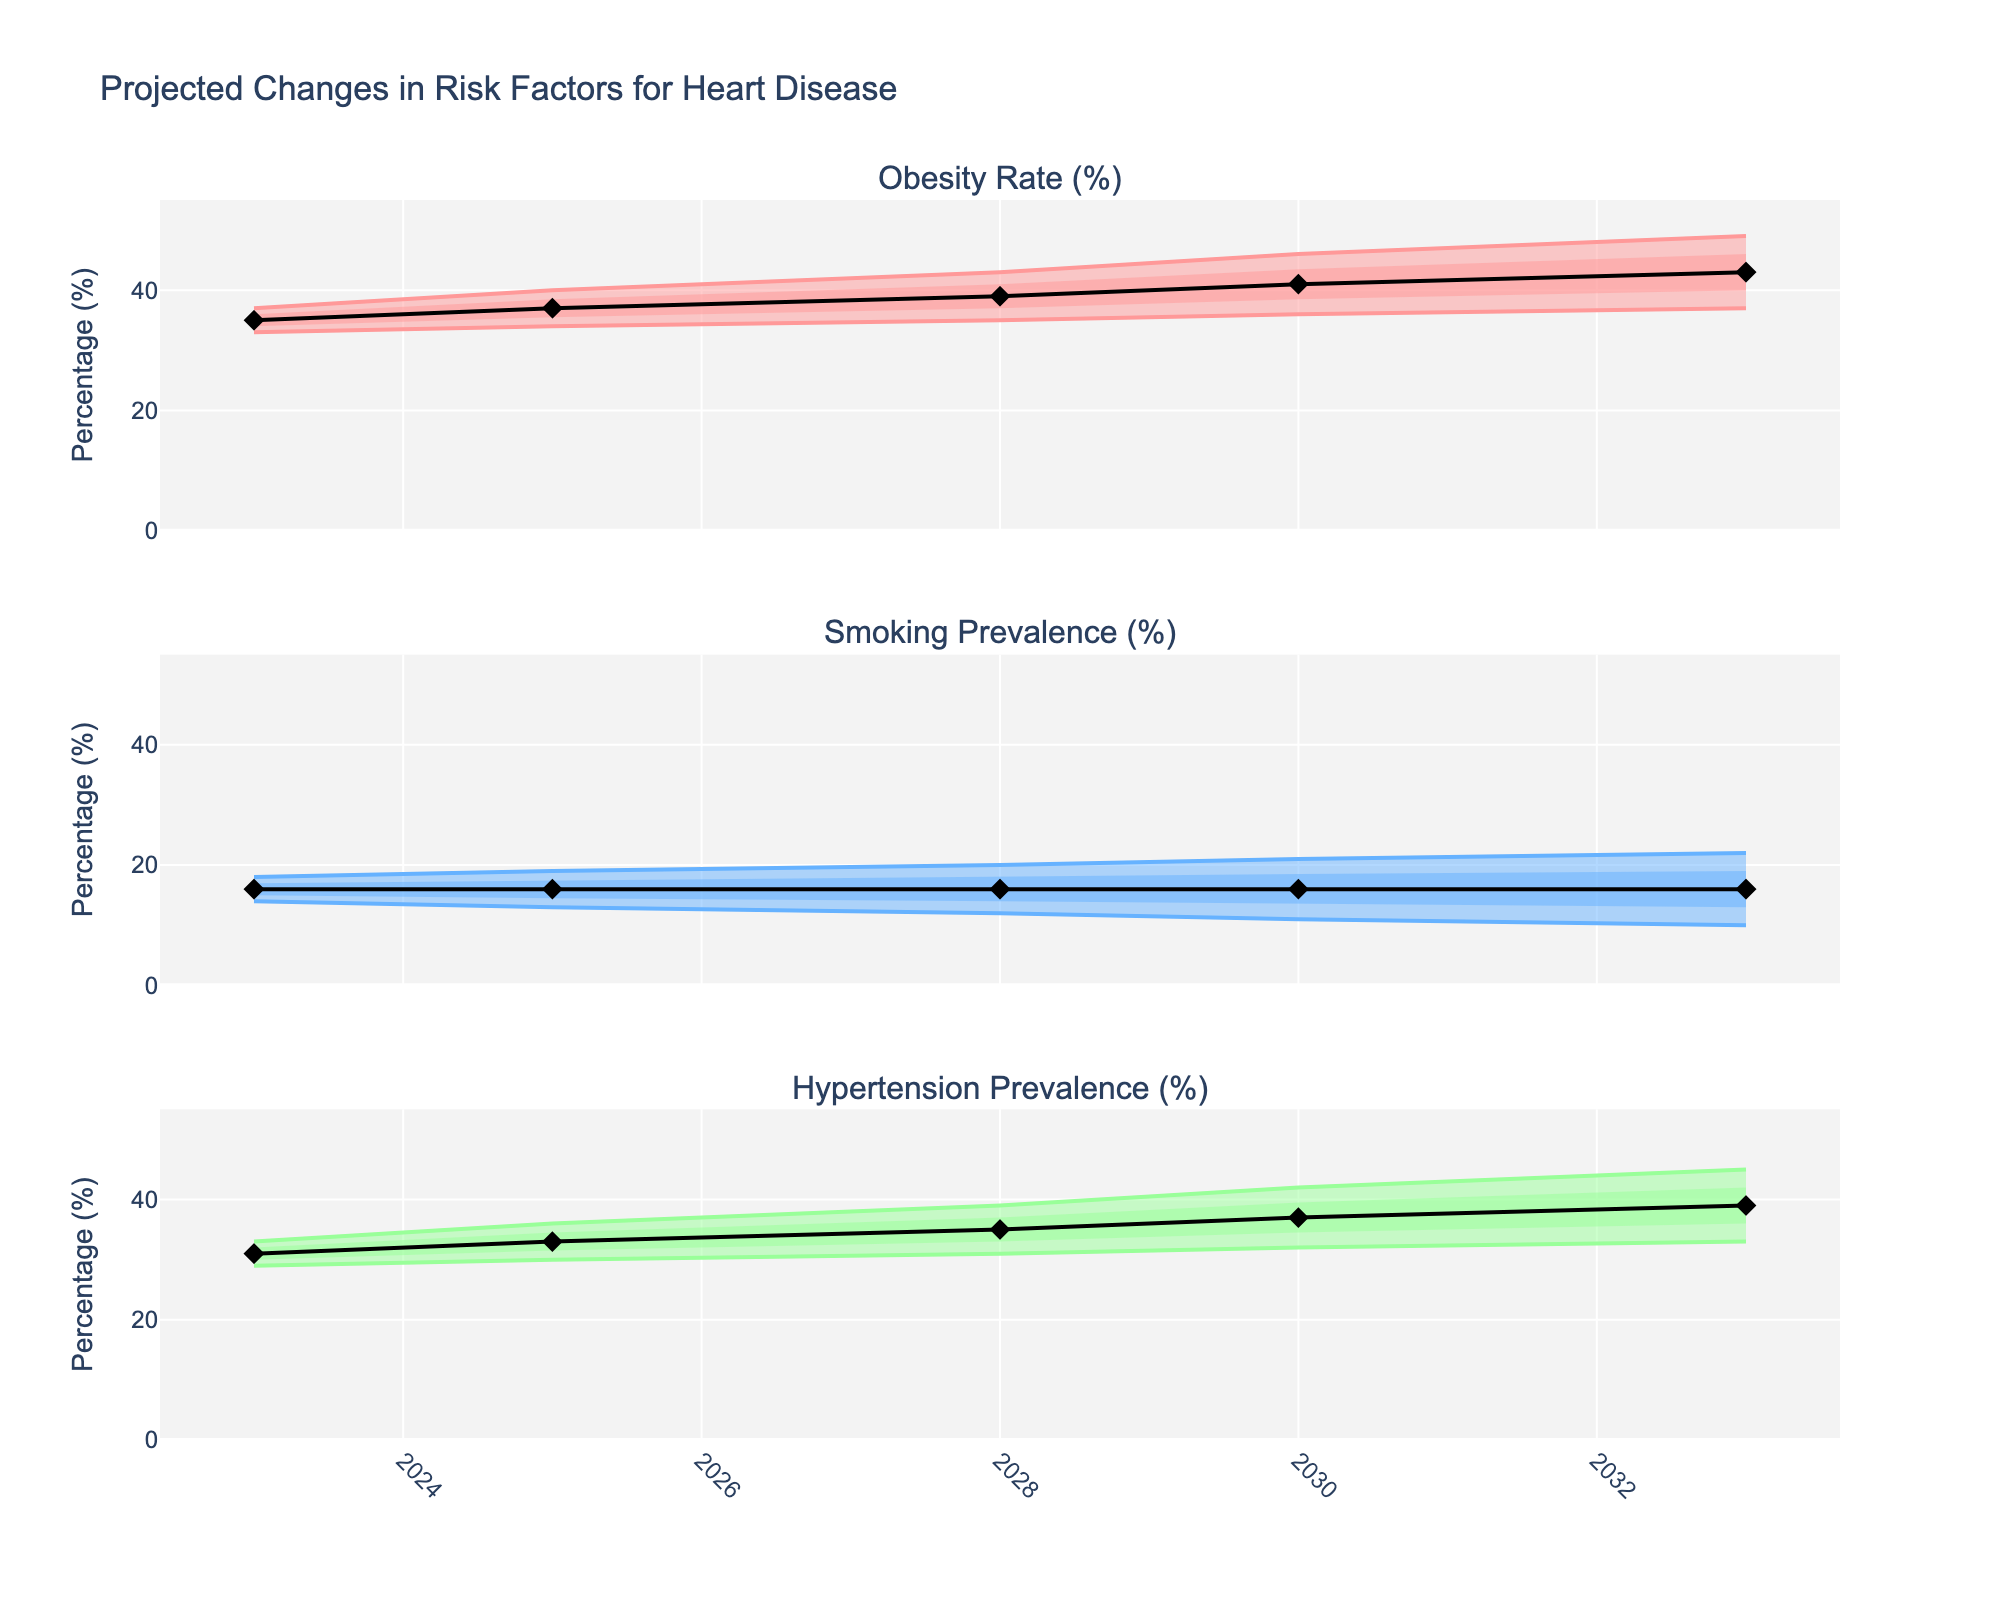What is the projected midpoint (Mid) percentage for obesity in 2030? The projected midpoint percentage for obesity in 2030 can be directly read from the Mid column for the year 2030 in the figure.
Answer: 41 How does the projected high estimate for smoking prevalence in 2033 compare to the high estimate in 2023? To compare, check the high estimate of smoking prevalence for 2023 and 2033 in the figure. In 2023 it is 18%, and in 2033 it is 22%. The high estimate increased by 4% over the decade.
Answer: Increased by 4% What is the range of hypertension prevalence projected for 2028? The range is the difference between the High and Low values in 2028. According to the figure, the Low value is 31% and the High value is 39%. The range is calculated as 39% - 31% = 8%.
Answer: 8% What trend can be observed in the midpoint values of obesity from 2023 to 2033? By observing the Mid values for obesity from 2023 to 2033, the midpoint values are increasing each year. They rise from 35% in 2023 to 43% in 2033, indicating a trend of increasing obesity rates.
Answer: Increasing trend Compare the trends in the midpoint values of smoking prevalence and hypertension prevalence from 2023 to 2033. To compare the trends, observe the midpoint values for smoking and hypertension from 2023 to 2033. For smoking prevalence, the midpoint is constant at 16% throughout the years. For hypertension, the midpoint increases from 31% in 2023 to 39% in 2033, indicating a rising trend for hypertension, while smoking remains constant.
Answer: Smoking: Constant, Hypertension: Increasing What is the projected midpoint (Mid) percentage for hypertension in 2025 and how does it compare to the midpoint percentage in 2023? The projected midpoint percentage for hypertension in 2025 is 33% and for 2023 it is 31%. Therefore, the midpoint for 2025 is 2% higher than that of 2023 (33% - 31% = 2%).
Answer: 2% higher In which year is the highest projected midpoint value for obesity observed? To find the highest projected midpoint value, look at the Mid values for obesity from 2023 to 2033. The highest value is 43%, which is observed in 2033.
Answer: 2033 What is the difference between the low-mid and mid-high estimates for hypertension prevalence in 2030? To find the difference, subtract the Low-Mid estimate from the Mid-High estimate for hypertension prevalence in 2030. The Low-Mid estimate is 34.5% and the Mid-High estimate is 39.5%. So, the difference is 39.5% - 34.5% = 5%.
Answer: 5% How do the trends for the high estimates of obesity and smoking prevalence compare from 2023 to 2033? Observe the high estimates for both obesity and smoking prevalence from 2023 to 2033. For obesity, the high estimate increases from 37% in 2023 to 49% in 2033. For smoking, the high estimate increases from 18% in 2023 to 22% in 2033. Both trends show an increase, but the increase in obesity is more pronounced.
Answer: Both increasing, but obesity increases more What color represents the confidence interval for smoking prevalence in the figure? The figure uses a specific color for each risk factor's confidence interval. By looking at the figure, we can identify that the color representing the smoking prevalence confidence interval is likely a light blue shade.
Answer: Light blue 